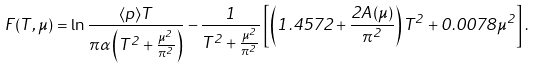<formula> <loc_0><loc_0><loc_500><loc_500>F ( T , \mu ) = \ln \frac { \langle p \rangle T } { \pi \alpha \left ( T ^ { 2 } + \frac { \mu ^ { 2 } } { \pi ^ { 2 } } \right ) } - \frac { 1 } { T ^ { 2 } + \frac { \mu ^ { 2 } } { \pi ^ { 2 } } } \left [ \left ( 1 . 4 5 7 2 + \frac { 2 A ( \mu ) } { \pi ^ { 2 } } \right ) T ^ { 2 } + 0 . 0 0 7 8 \mu ^ { 2 } \right ] .</formula> 